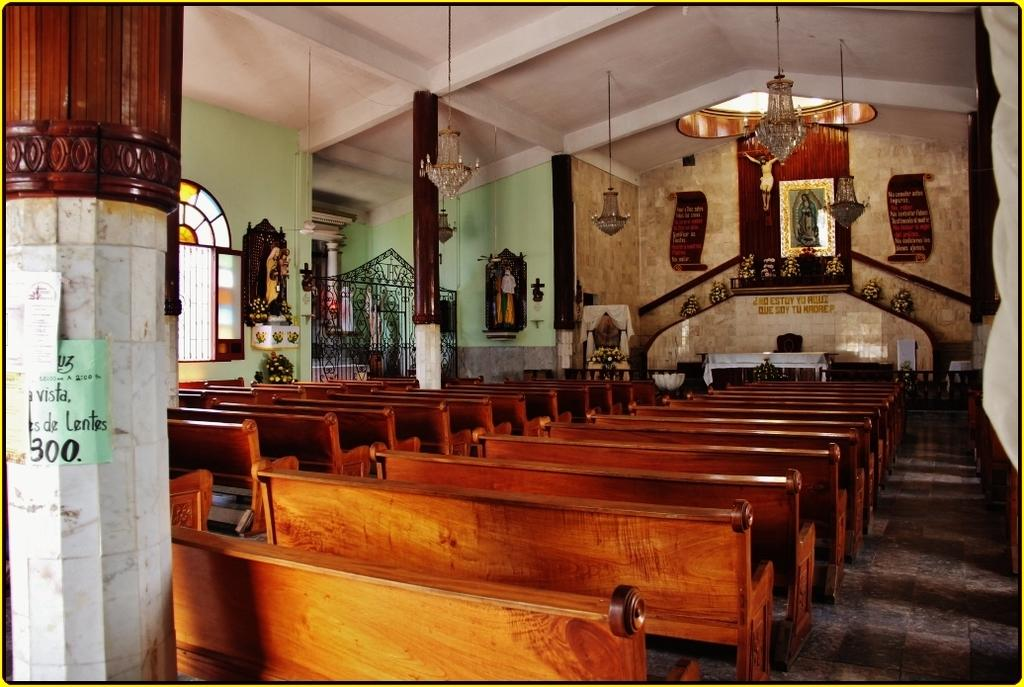What type of structure can be seen in the image? There is a wall in the image. What type of lighting is present in the image? There are chandeliers in the image. What allows natural light to enter the space in the image? There is a window in the image. What type of seating is available in the image? There are benches in the image. What type of decorative object is present in the image? There is a statue in the image. What type of plant is growing on the statue in the image? There is no plant growing on the statue in the image. What type of rod is used to control the chandeliers in the image? There is no rod present in the image to control the chandeliers. 